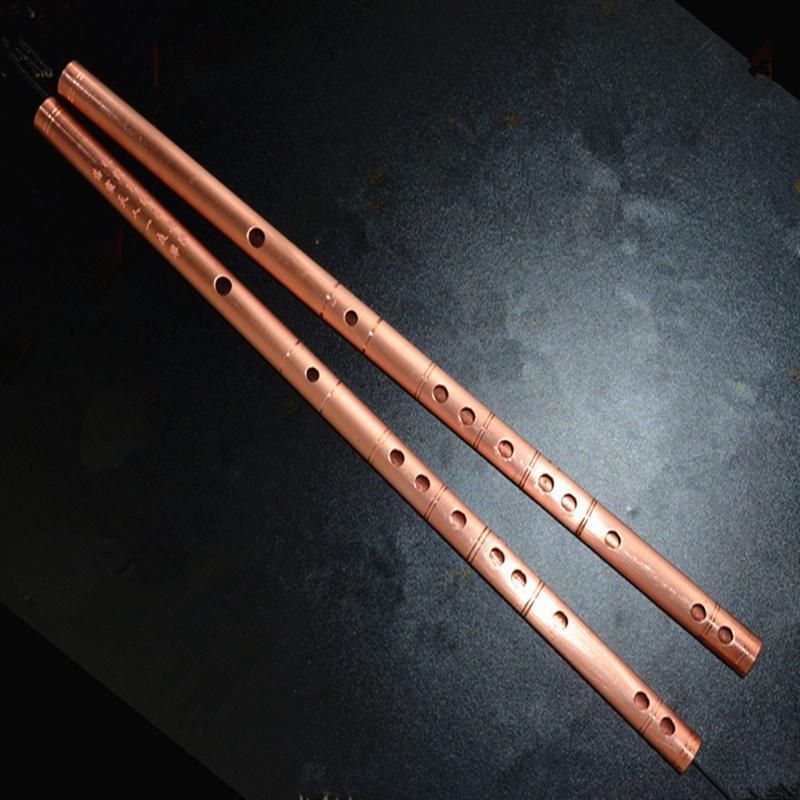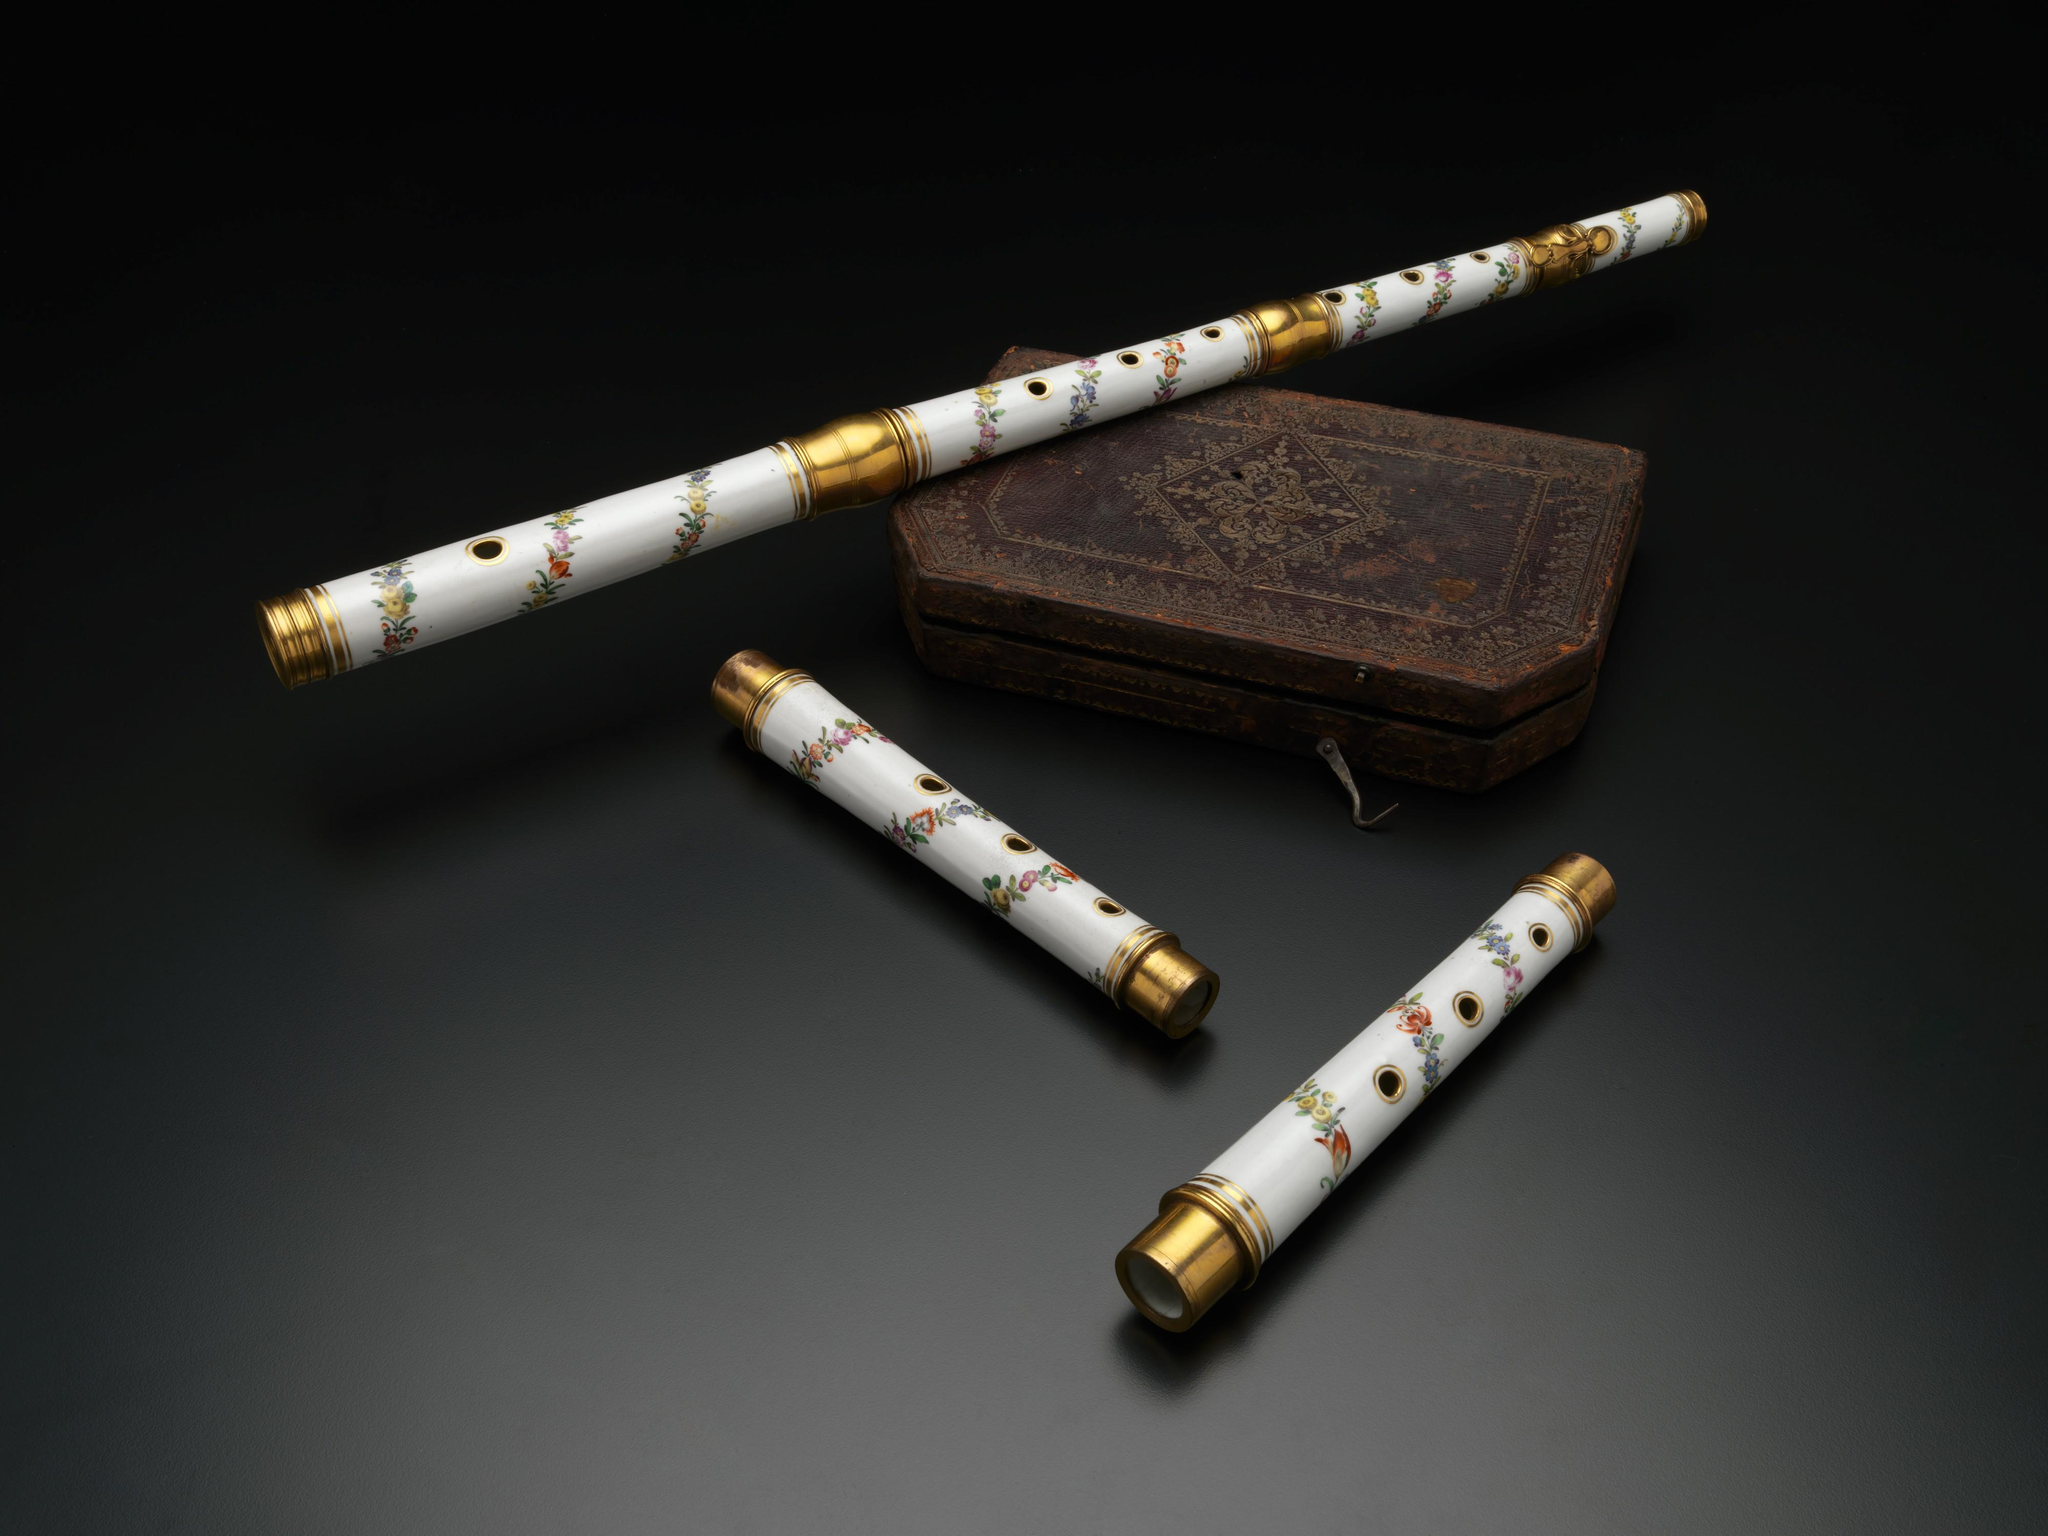The first image is the image on the left, the second image is the image on the right. Evaluate the accuracy of this statement regarding the images: "There are two instruments in the image on the left.". Is it true? Answer yes or no. Yes. 